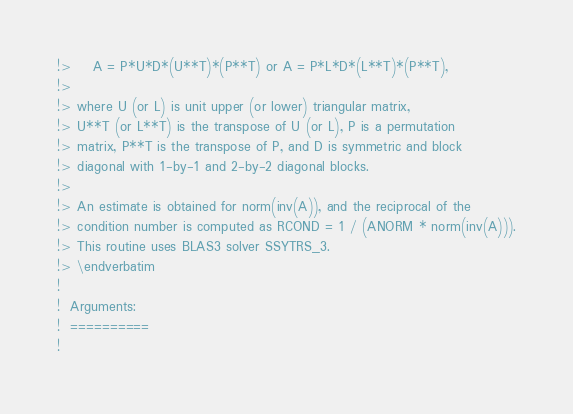Convert code to text. <code><loc_0><loc_0><loc_500><loc_500><_FORTRAN_>!>    A = P*U*D*(U**T)*(P**T) or A = P*L*D*(L**T)*(P**T),
!>
!> where U (or L) is unit upper (or lower) triangular matrix,
!> U**T (or L**T) is the transpose of U (or L), P is a permutation
!> matrix, P**T is the transpose of P, and D is symmetric and block
!> diagonal with 1-by-1 and 2-by-2 diagonal blocks.
!>
!> An estimate is obtained for norm(inv(A)), and the reciprocal of the
!> condition number is computed as RCOND = 1 / (ANORM * norm(inv(A))).
!> This routine uses BLAS3 solver SSYTRS_3.
!> \endverbatim
!
!  Arguments:
!  ==========
!</code> 